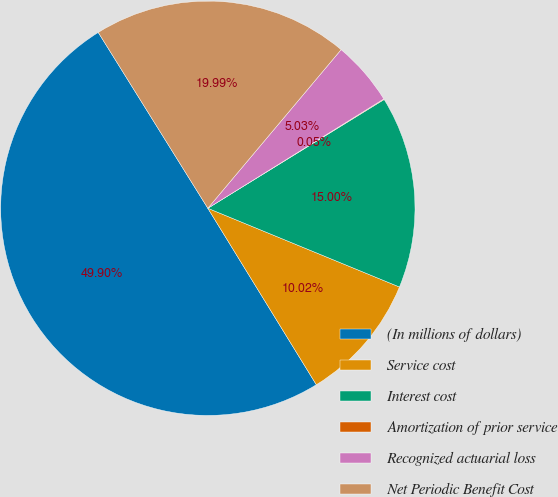Convert chart to OTSL. <chart><loc_0><loc_0><loc_500><loc_500><pie_chart><fcel>(In millions of dollars)<fcel>Service cost<fcel>Interest cost<fcel>Amortization of prior service<fcel>Recognized actuarial loss<fcel>Net Periodic Benefit Cost<nl><fcel>49.9%<fcel>10.02%<fcel>15.0%<fcel>0.05%<fcel>5.03%<fcel>19.99%<nl></chart> 